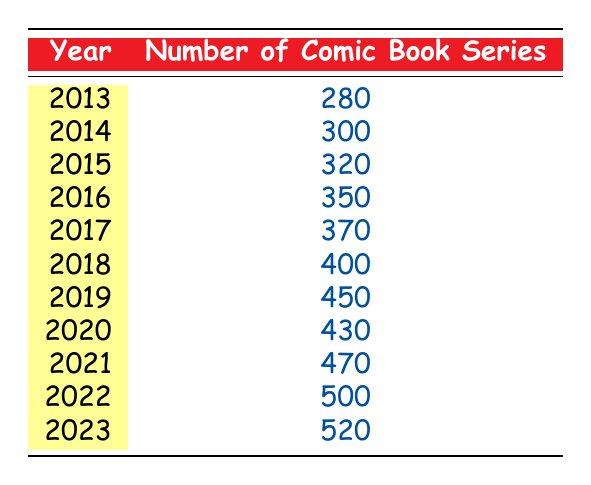What was the number of comic book series published in 2015? The table shows that in 2015, the number of comic book series published was listed directly under that year, which is 320.
Answer: 320 What is the year with the highest number of comic book series published? From examining the table, the year with the highest number is 2023, where 520 comic book series were published.
Answer: 2023 What was the difference in the number of comic book series published between 2018 and 2020? To find the difference, take the number from 2018 (400) and subtract the number from 2020 (430). This gives 400 - 430 = -30. Therefore, there were 30 fewer series published in 2020 compared to 2018.
Answer: -30 Is it true that more than 400 comic book series were published in 2019? Checking the table, in 2019, it shows that the number of series published was 450, which is indeed more than 400.
Answer: Yes What is the average number of comic book series published annually from 2013 to 2023? First, calculate the total number of comic book series published from 2013 to 2023. The sum is 280 + 300 + 320 + 350 + 370 + 400 + 450 + 430 + 470 + 500 + 520 = 4,870. There are 11 years in total, so the average is 4,870 / 11 = 443.18.
Answer: 443.18 How many comic book series were published from 2017 to 2021? To find this, sum the number of series published in each year from 2017 to 2021: 370 (2017) + 400 (2018) + 450 (2019) + 430 (2020) + 470 (2021) = 2,120.
Answer: 2120 What was the trend in the number of comic book series published from 2013 to 2023? By observing the table, the trend shows a general increase in the number of comic book series published each year, with only a slight drop from 2019 to 2020 before continuing to rise again.
Answer: Increase with a slight drop in 2020 Did the number of comic book series published increase every year? Analyzing the table shows a decrease from 2019 to 2020 from 450 to 430, indicating that not every year saw an increase.
Answer: No 